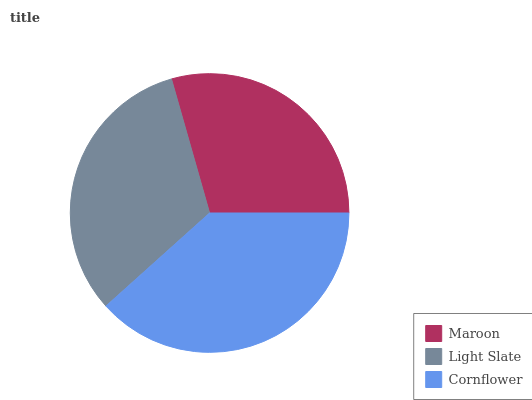Is Maroon the minimum?
Answer yes or no. Yes. Is Cornflower the maximum?
Answer yes or no. Yes. Is Light Slate the minimum?
Answer yes or no. No. Is Light Slate the maximum?
Answer yes or no. No. Is Light Slate greater than Maroon?
Answer yes or no. Yes. Is Maroon less than Light Slate?
Answer yes or no. Yes. Is Maroon greater than Light Slate?
Answer yes or no. No. Is Light Slate less than Maroon?
Answer yes or no. No. Is Light Slate the high median?
Answer yes or no. Yes. Is Light Slate the low median?
Answer yes or no. Yes. Is Cornflower the high median?
Answer yes or no. No. Is Maroon the low median?
Answer yes or no. No. 